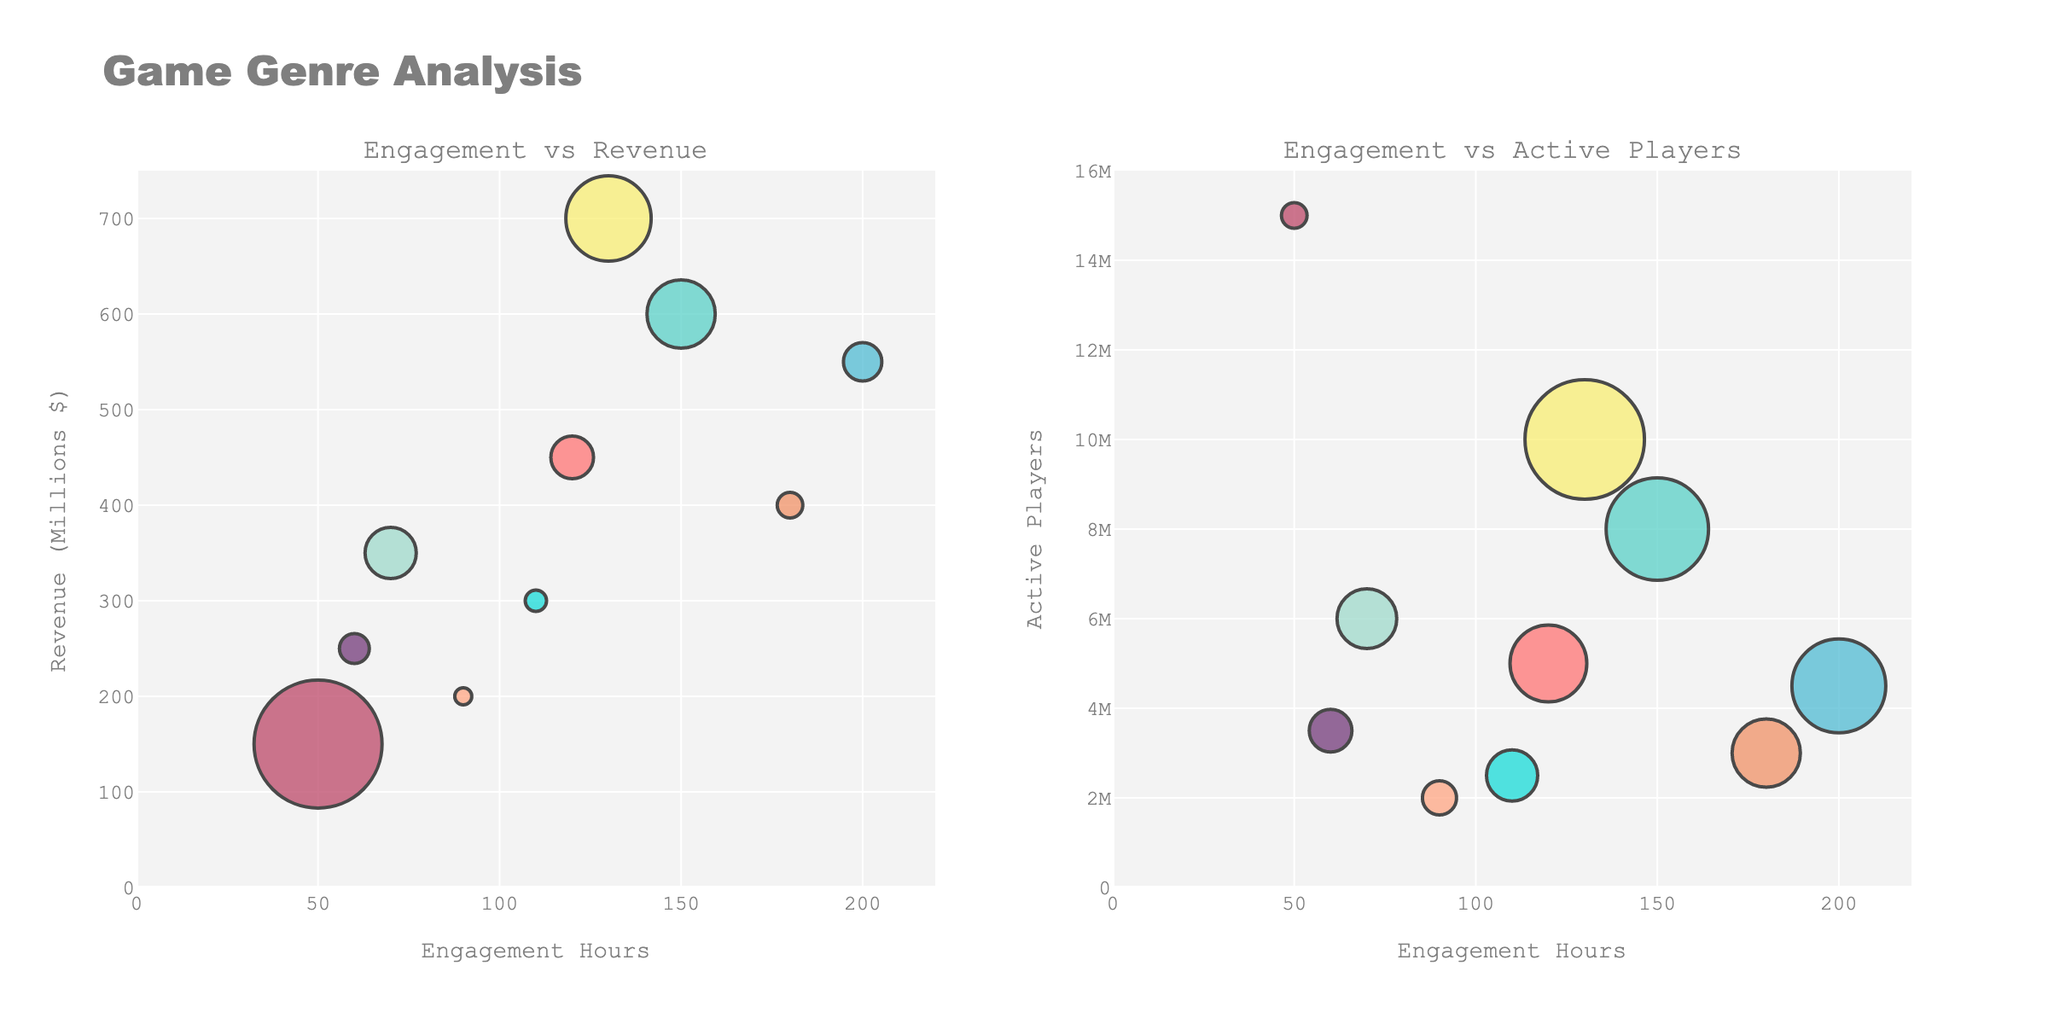What are the album sales in millions for Beyoncé in 2013? Look at the bar labeled "Beyoncé" in the subplot for 2013, and read the value indicated by the bar.
Answer: 5.1 How much more did Adele sell compared to Ed Sheeran in 2015? Locate the bars for Adele and Ed Sheeran in the 2015 subplot, and subtract Ed Sheeran's sales (6.2) from Adele's sales (17.4).
Answer: 11.2 Compare the album sales of Female and Male artists in 2017. Which gender had higher sales? Add the sales of female artists (Taylor Swift, 4.5) and male artists (Bruno Mars, 2.8) in the 2017 subplot, and compare the totals.
Answer: Female What is the total album sales of female artists across all years shown? Sum the sales of female artists for each year: 5.1 (2013) + 17.4 (2015) + 4.5 (2017) + 3.7 (2019) + 2.6 (2021).
Answer: 33.3 Which year had the highest sales for a female artist, and who was the artist? Examine each subplot and identify the female artist with the highest sales bar; check the year.
Answer: 2015, Adele What is the average album sales for male artists in 2019 and 2021 combined? Locate sales for Post Malone (3.2) in 2019 and The Weeknd (2.3) in 2021, then calculate the average: (3.2 + 2.3)/2.
Answer: 2.75 Which artist had the lowest album sales in 2021, and what was the value? Look at both bars in the 2021 subplot and identify the shorter bar, noting both the artist and the sales value.
Answer: The Weeknd, 2.3 Are there more male or female artists listed across all years? Count the number of male (5) and female (5) artists based on the subplots, then compare the counts.
Answer: Equal In the chart for 2013, what is the difference in album sales between Beyoncé and Justin Timberlake? Subtract Justin Timberlake's sales (3.5) from Beyoncé's sales (5.1) in the 2013 subplot.
Answer: 1.6 Which female artist had the lowest album sales in the dataset, and in what year? Identify the shortest bar among all female artists across the subplots and note the artist and year.
Answer: Billie Eilish, 2021 